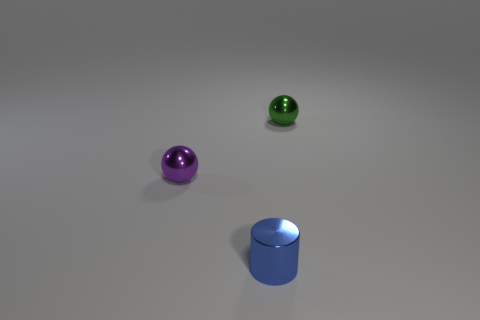Add 1 brown matte spheres. How many objects exist? 4 Subtract 1 spheres. How many spheres are left? 1 Subtract all green balls. How many balls are left? 1 Add 1 tiny purple metal spheres. How many tiny purple metal spheres are left? 2 Add 2 small blue cylinders. How many small blue cylinders exist? 3 Subtract 0 gray cubes. How many objects are left? 3 Subtract all cylinders. How many objects are left? 2 Subtract all gray cylinders. Subtract all gray balls. How many cylinders are left? 1 Subtract all brown cylinders. How many red spheres are left? 0 Subtract all tiny green things. Subtract all purple balls. How many objects are left? 1 